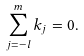<formula> <loc_0><loc_0><loc_500><loc_500>\sum _ { j = - l } ^ { m } k _ { j } = 0 . \,</formula> 